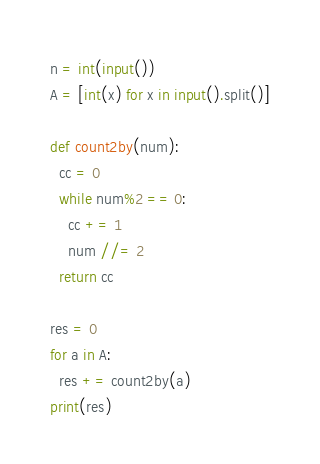Convert code to text. <code><loc_0><loc_0><loc_500><loc_500><_Python_>n = int(input())
A = [int(x) for x in input().split()]

def count2by(num):
  cc = 0
  while num%2 == 0:
    cc += 1
    num //= 2
  return cc

res = 0
for a in A:
  res += count2by(a)
print(res)</code> 